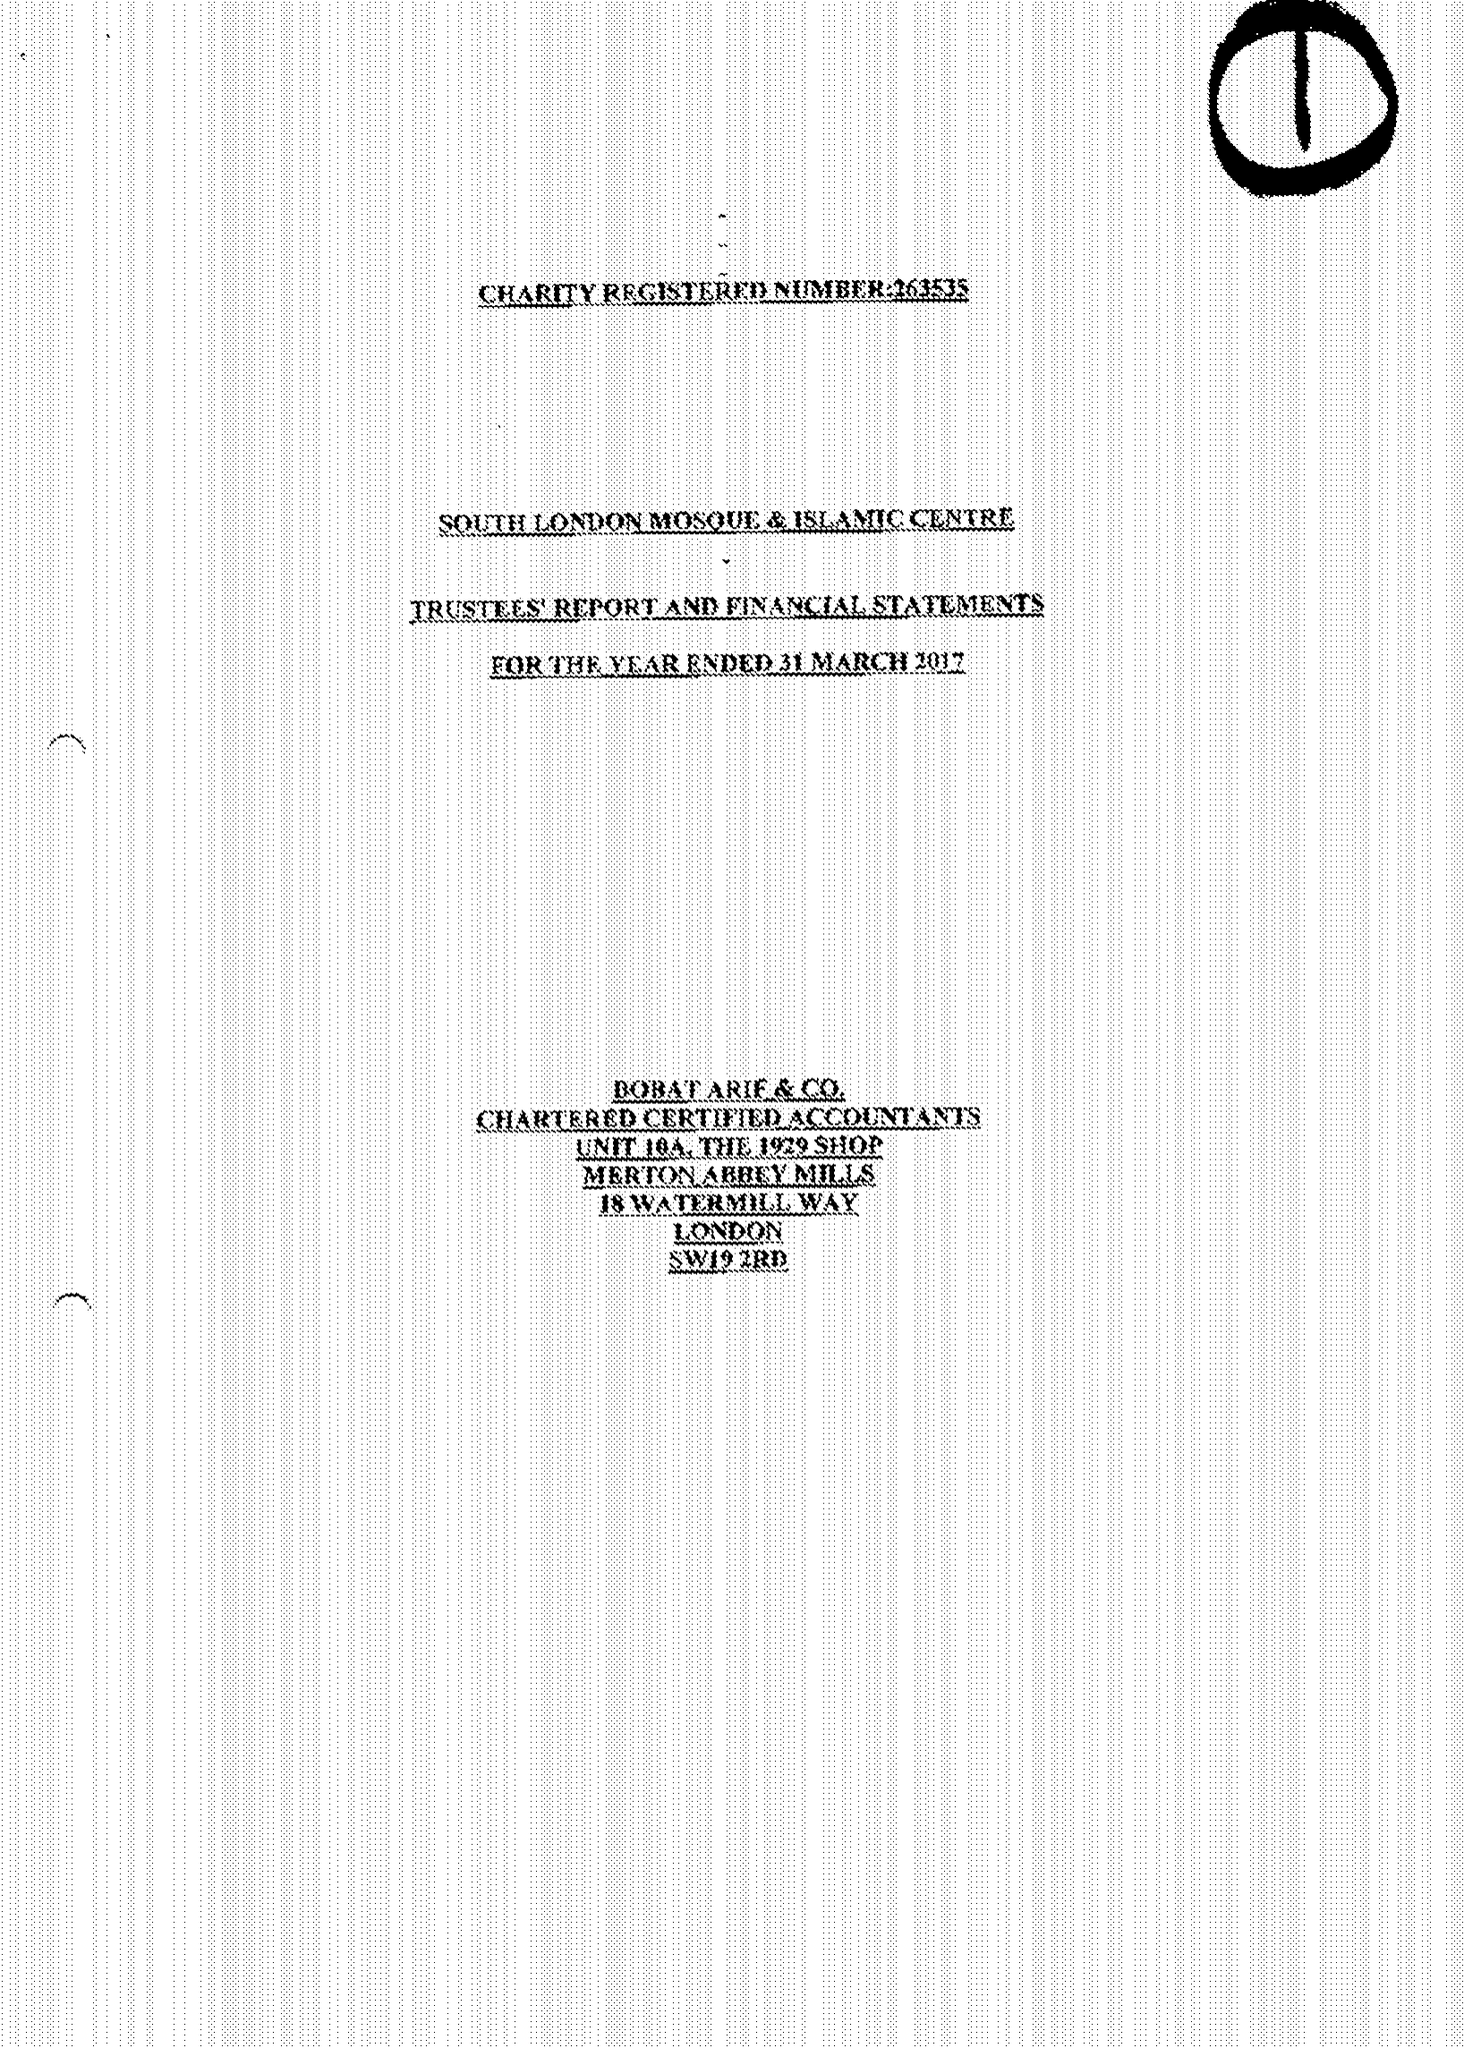What is the value for the address__post_town?
Answer the question using a single word or phrase. LONDON 